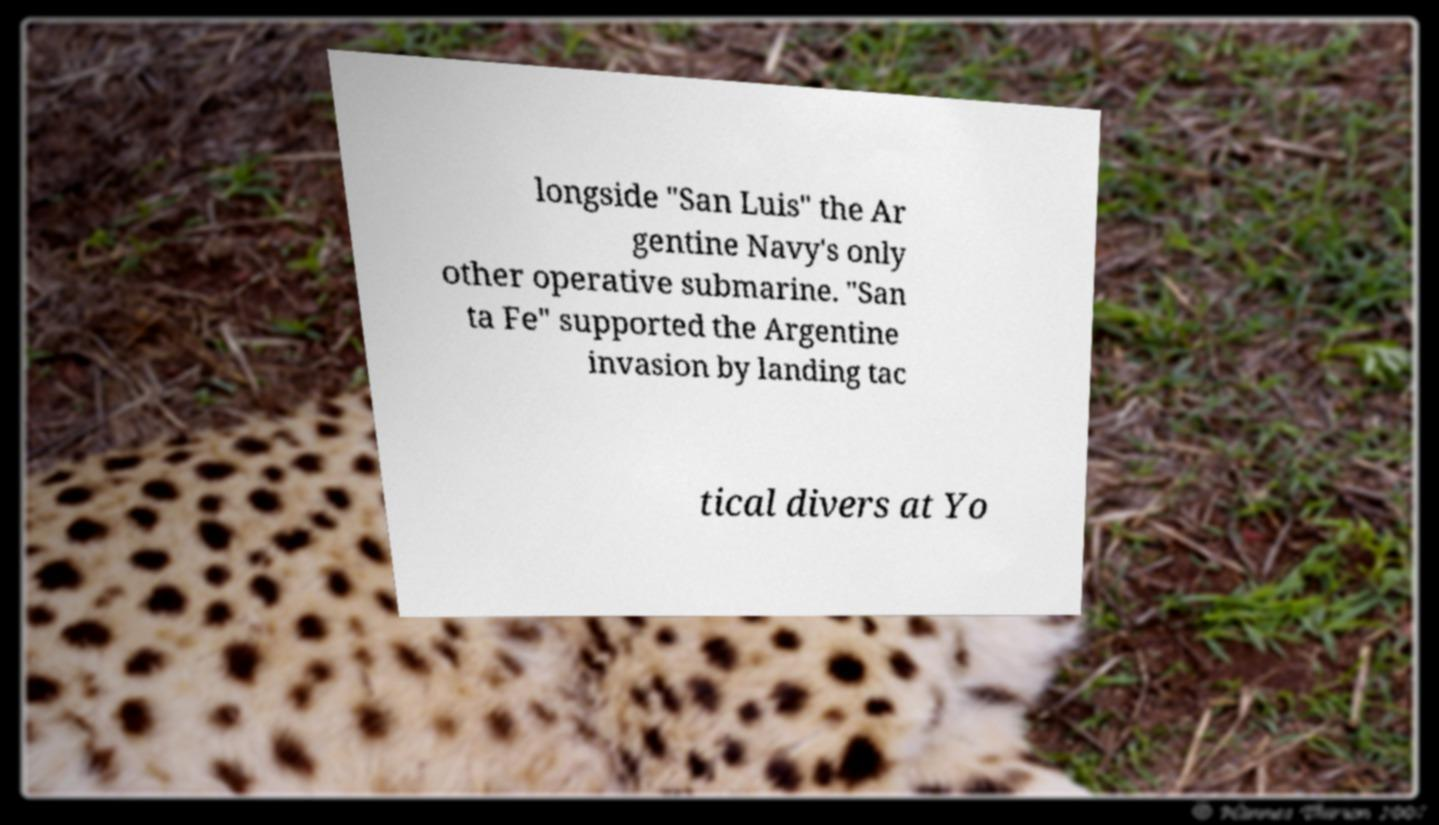Can you read and provide the text displayed in the image?This photo seems to have some interesting text. Can you extract and type it out for me? longside "San Luis" the Ar gentine Navy's only other operative submarine. "San ta Fe" supported the Argentine invasion by landing tac tical divers at Yo 